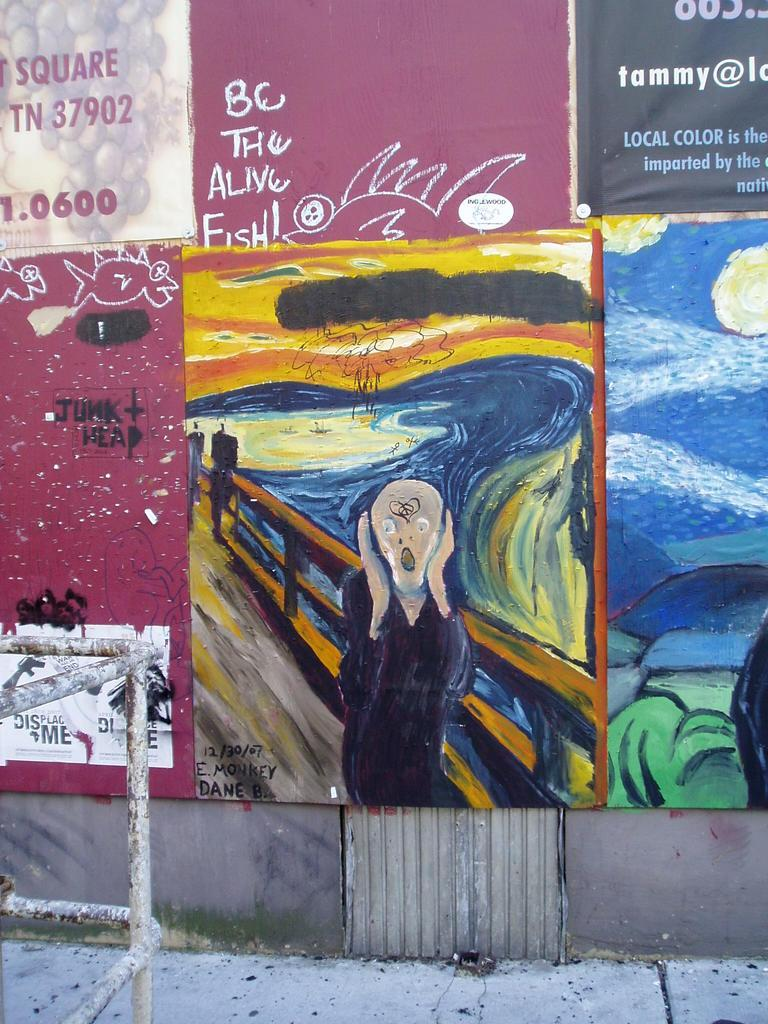<image>
Create a compact narrative representing the image presented. The email address of a woman named Tammy is one of many things decorating a public wall. 